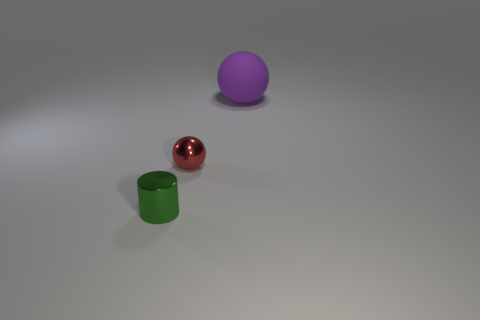Subtract all yellow cylinders. Subtract all yellow spheres. How many cylinders are left? 1 Add 1 tiny green cylinders. How many objects exist? 4 Subtract all cylinders. How many objects are left? 2 Add 3 small red shiny balls. How many small red shiny balls exist? 4 Subtract 0 brown blocks. How many objects are left? 3 Subtract all small blue matte cylinders. Subtract all green shiny objects. How many objects are left? 2 Add 1 tiny things. How many tiny things are left? 3 